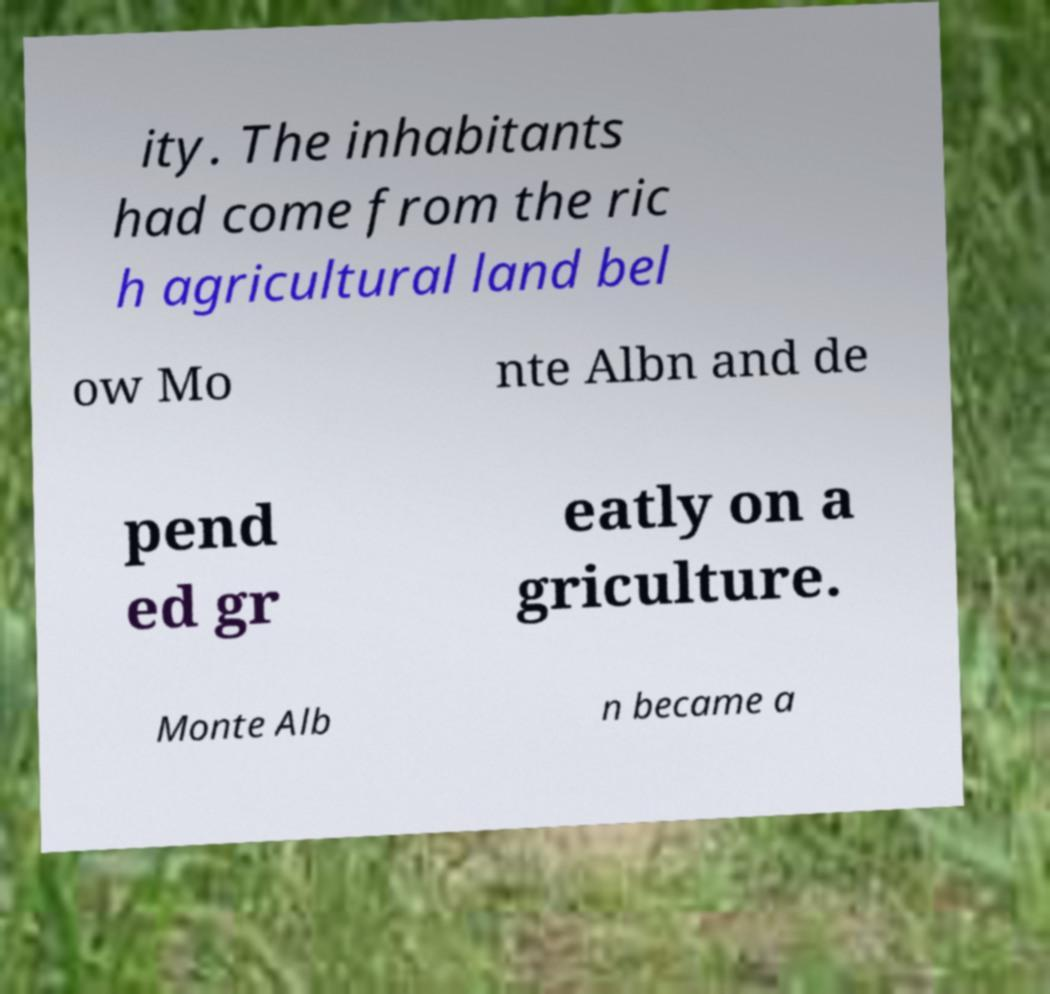Please identify and transcribe the text found in this image. ity. The inhabitants had come from the ric h agricultural land bel ow Mo nte Albn and de pend ed gr eatly on a griculture. Monte Alb n became a 